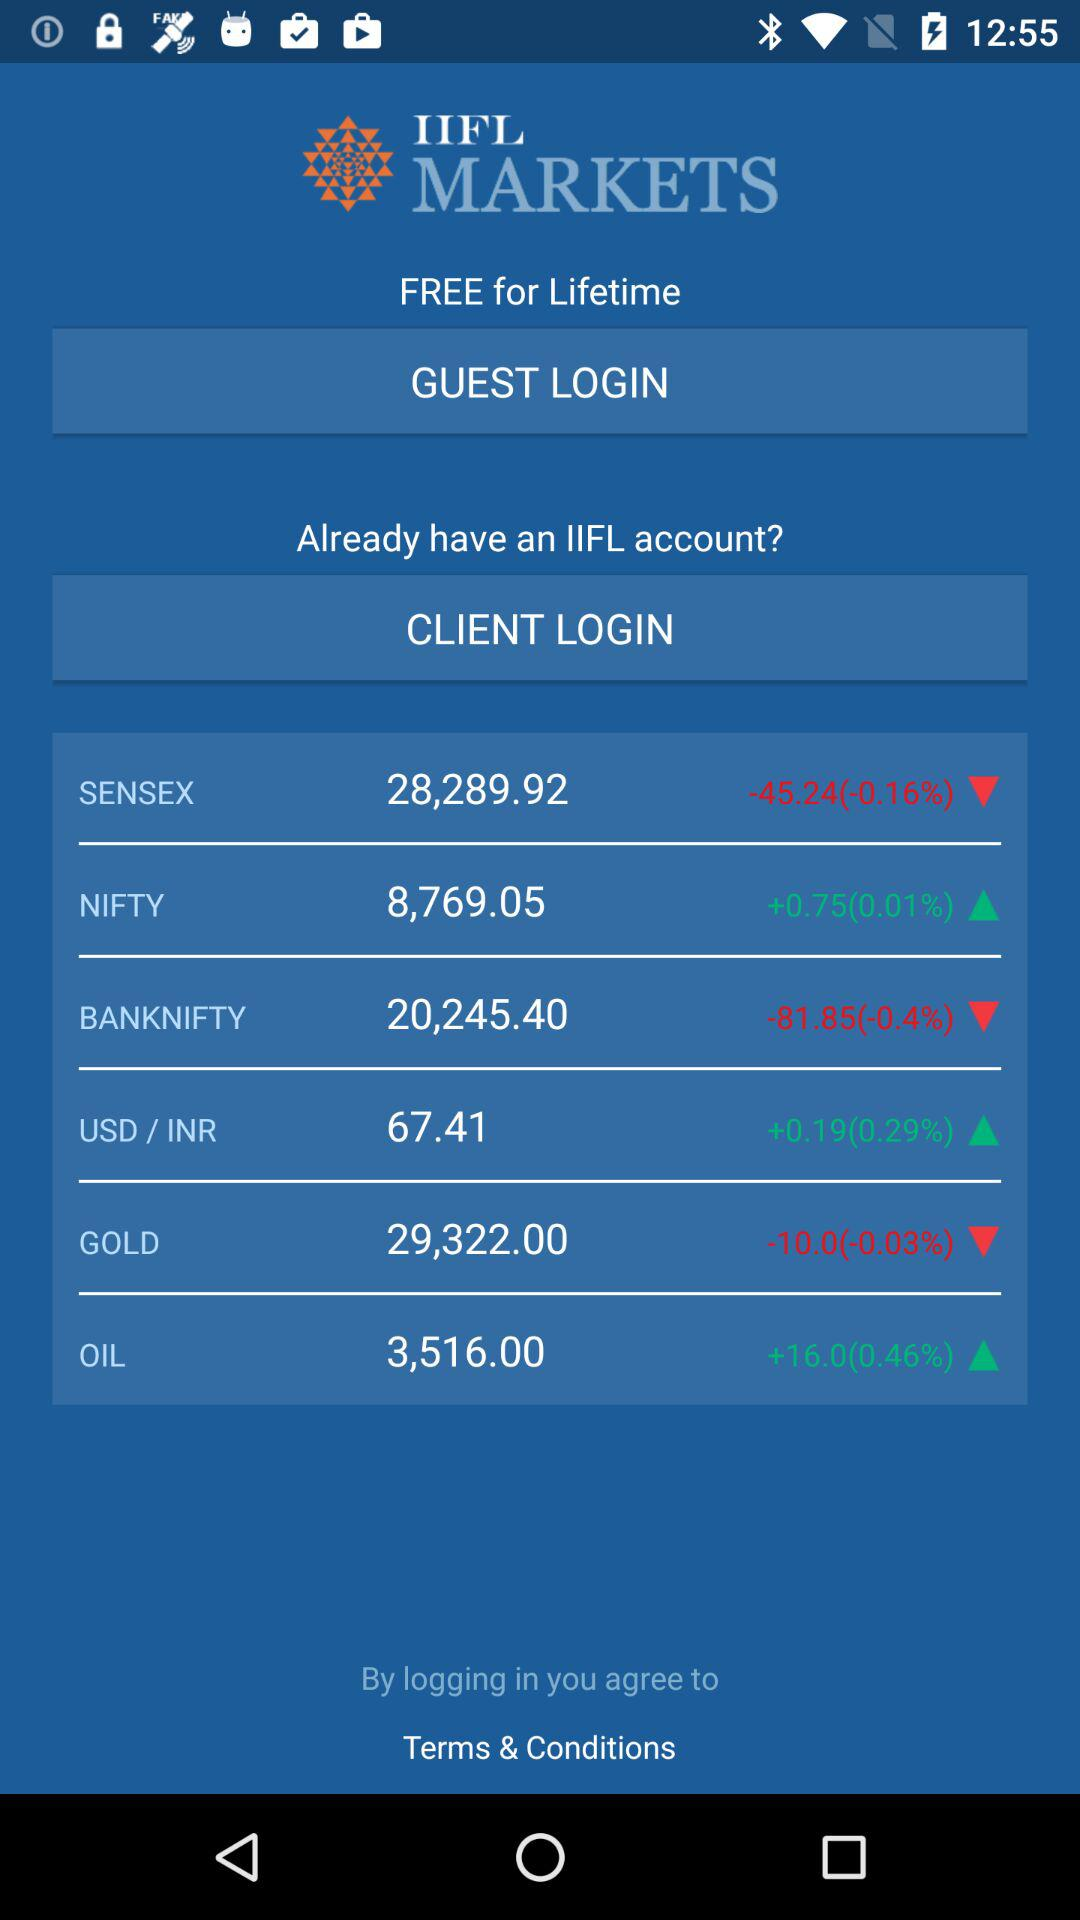What is the current rate of NIFTY? The current rate of NIFTY is 8,769.05. 